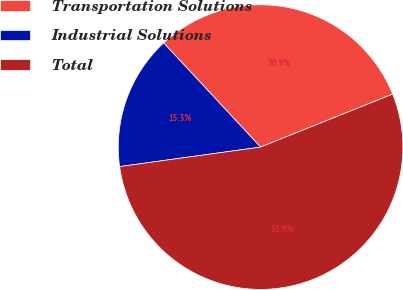Convert chart. <chart><loc_0><loc_0><loc_500><loc_500><pie_chart><fcel>Transportation Solutions<fcel>Industrial Solutions<fcel>Total<nl><fcel>30.86%<fcel>15.26%<fcel>53.88%<nl></chart> 